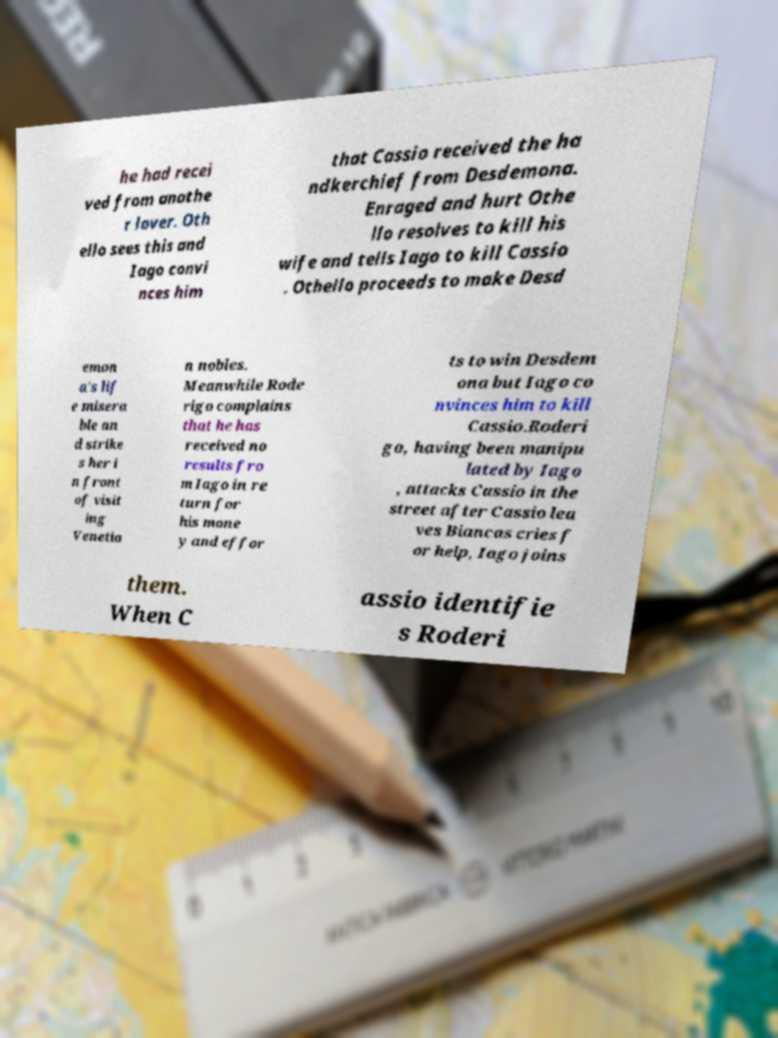Please identify and transcribe the text found in this image. he had recei ved from anothe r lover. Oth ello sees this and Iago convi nces him that Cassio received the ha ndkerchief from Desdemona. Enraged and hurt Othe llo resolves to kill his wife and tells Iago to kill Cassio . Othello proceeds to make Desd emon a's lif e misera ble an d strike s her i n front of visit ing Venetia n nobles. Meanwhile Rode rigo complains that he has received no results fro m Iago in re turn for his mone y and effor ts to win Desdem ona but Iago co nvinces him to kill Cassio.Roderi go, having been manipu lated by Iago , attacks Cassio in the street after Cassio lea ves Biancas cries f or help, Iago joins them. When C assio identifie s Roderi 